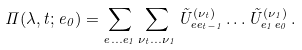Convert formula to latex. <formula><loc_0><loc_0><loc_500><loc_500>\Pi ( \lambda , t ; e _ { 0 } ) = \sum _ { e \dots e _ { 1 } } \sum _ { \nu _ { t } \dots \nu _ { 1 } } \tilde { U } _ { e e _ { t - 1 } } ^ { ( \nu _ { t } ) } \dots \tilde { U } _ { e _ { 1 } e _ { 0 } } ^ { ( \nu _ { 1 } ) } \, .</formula> 